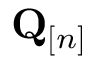<formula> <loc_0><loc_0><loc_500><loc_500>\mathbf Q _ { [ n ] }</formula> 